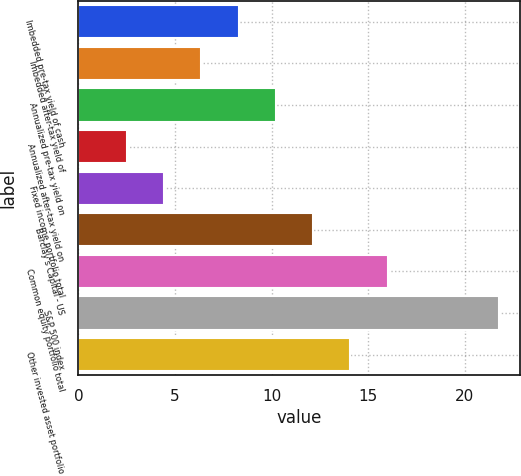Convert chart to OTSL. <chart><loc_0><loc_0><loc_500><loc_500><bar_chart><fcel>Imbedded pre-tax yield of cash<fcel>Imbedded after-tax yield of<fcel>Annualized pre-tax yield on<fcel>Annualized after-tax yield on<fcel>Fixed income portfolio total<fcel>Barclay's Capital - US<fcel>Common equity portfolio total<fcel>S&P 500 index<fcel>Other invested asset portfolio<nl><fcel>8.29<fcel>6.36<fcel>10.22<fcel>2.5<fcel>4.43<fcel>12.15<fcel>16.01<fcel>21.8<fcel>14.08<nl></chart> 